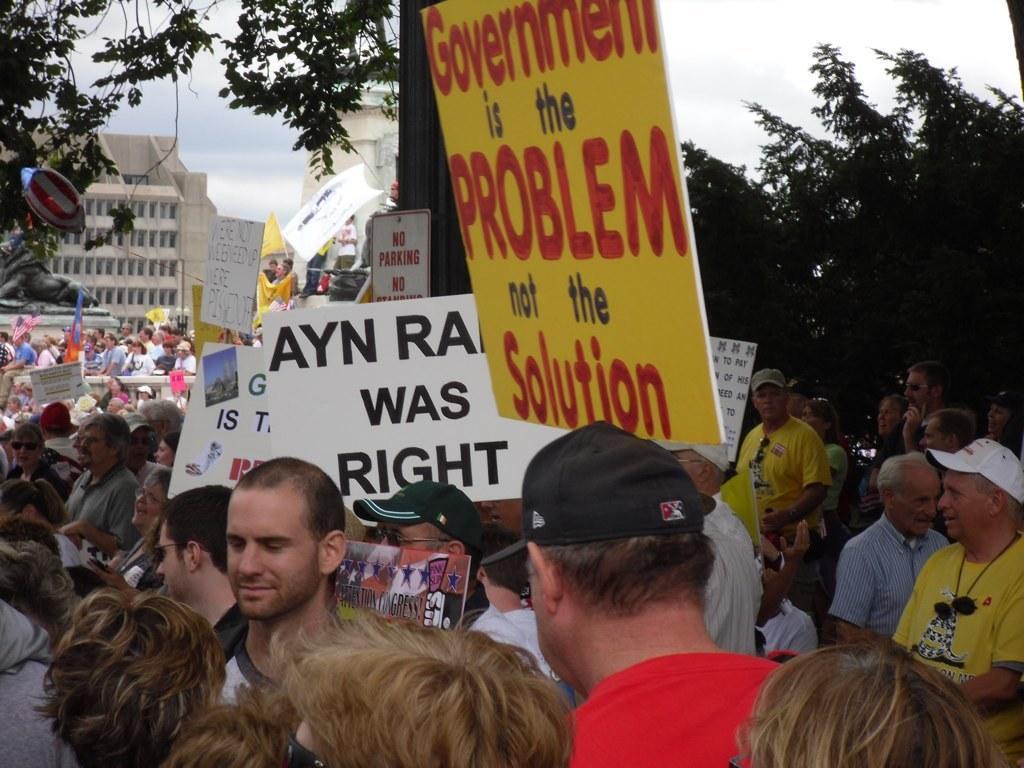Can you describe this image briefly? In this image I can see group of people some are standing and some are sitting. I can see few boards in yellow and white color, background I can see trees in green color, few buildings in white color and the sky is in white color. 